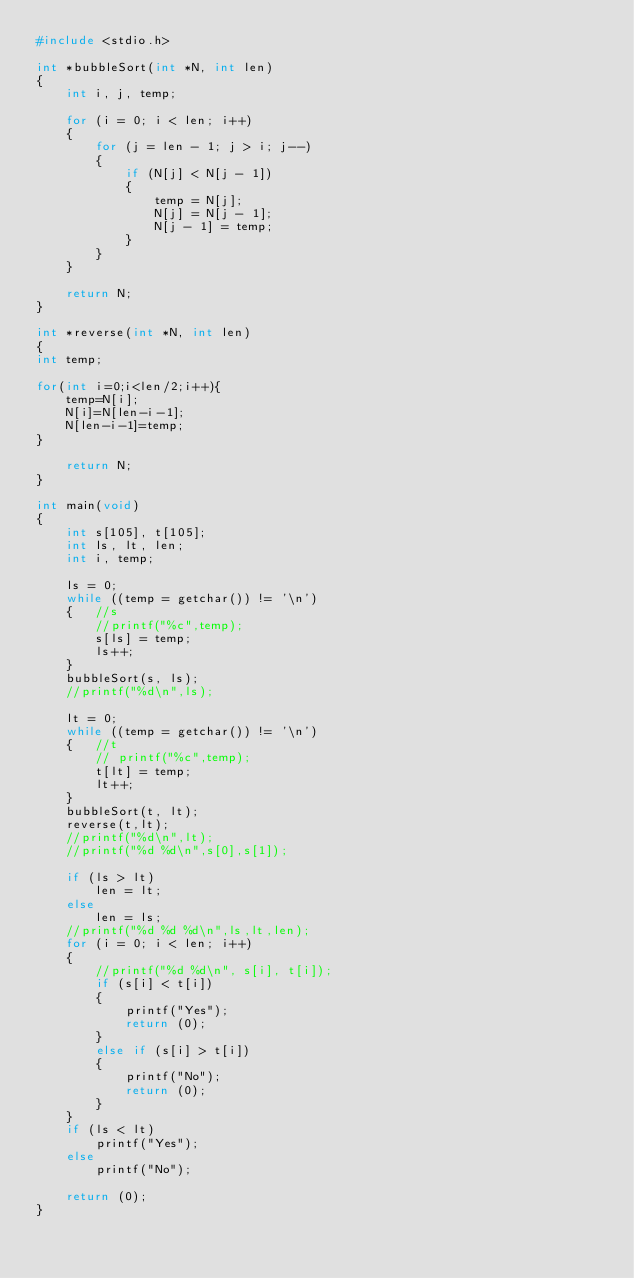<code> <loc_0><loc_0><loc_500><loc_500><_C_>#include <stdio.h>

int *bubbleSort(int *N, int len)
{
    int i, j, temp;

    for (i = 0; i < len; i++)
    {
        for (j = len - 1; j > i; j--)
        {
            if (N[j] < N[j - 1])
            {
                temp = N[j];
                N[j] = N[j - 1];
                N[j - 1] = temp;
            }
        }
    }

    return N;
}

int *reverse(int *N, int len)
{
int temp;

for(int i=0;i<len/2;i++){
    temp=N[i];
    N[i]=N[len-i-1];
    N[len-i-1]=temp;
}

    return N;
}

int main(void)
{
    int s[105], t[105];
    int ls, lt, len;
    int i, temp;

    ls = 0;
    while ((temp = getchar()) != '\n')
    {   //s
        //printf("%c",temp);
        s[ls] = temp;
        ls++;
    }
    bubbleSort(s, ls);
    //printf("%d\n",ls);

    lt = 0;
    while ((temp = getchar()) != '\n')
    {   //t
        // printf("%c",temp);
        t[lt] = temp;
        lt++;
    }
    bubbleSort(t, lt);
    reverse(t,lt);
    //printf("%d\n",lt);
    //printf("%d %d\n",s[0],s[1]);

    if (ls > lt)
        len = lt;
    else
        len = ls;
    //printf("%d %d %d\n",ls,lt,len);
    for (i = 0; i < len; i++)
    {
        //printf("%d %d\n", s[i], t[i]);
        if (s[i] < t[i])
        {
            printf("Yes");
            return (0);
        }
        else if (s[i] > t[i])
        {
            printf("No");
            return (0);
        }
    }
    if (ls < lt)
        printf("Yes");
    else
        printf("No");

    return (0);
}</code> 